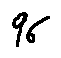Convert formula to latex. <formula><loc_0><loc_0><loc_500><loc_500>9 6</formula> 